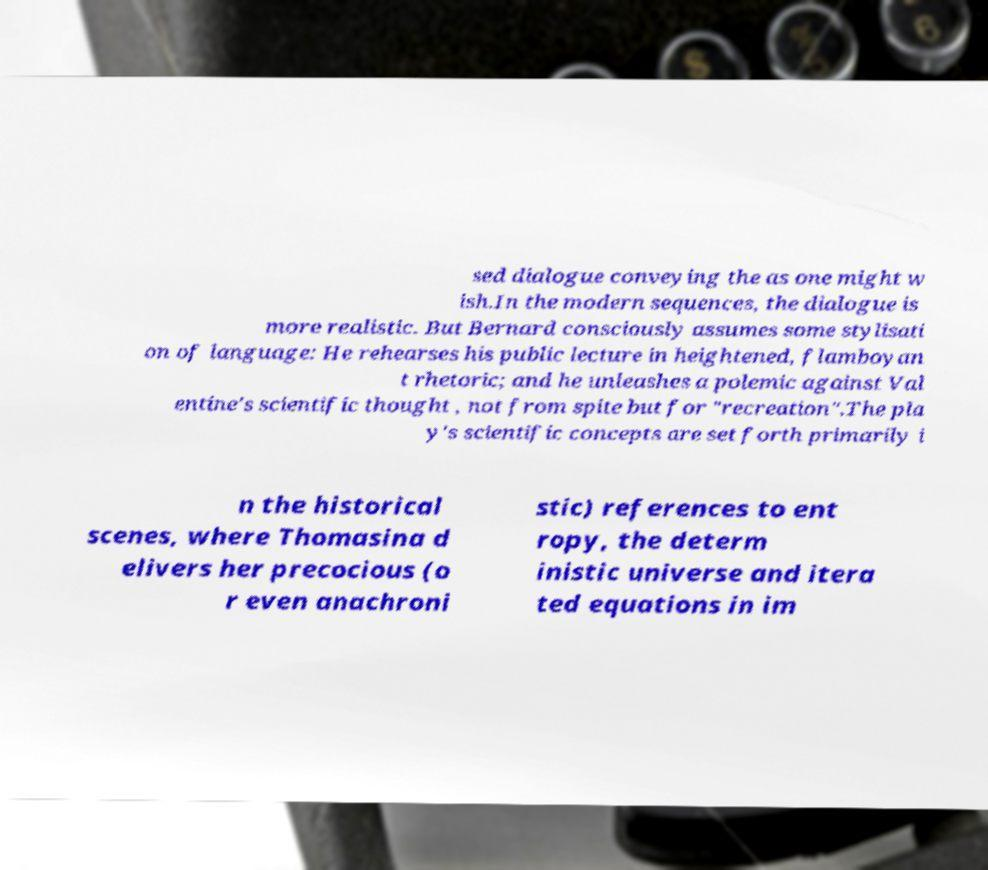Please read and relay the text visible in this image. What does it say? sed dialogue conveying the as one might w ish.In the modern sequences, the dialogue is more realistic. But Bernard consciously assumes some stylisati on of language: He rehearses his public lecture in heightened, flamboyan t rhetoric; and he unleashes a polemic against Val entine's scientific thought , not from spite but for "recreation".The pla y's scientific concepts are set forth primarily i n the historical scenes, where Thomasina d elivers her precocious (o r even anachroni stic) references to ent ropy, the determ inistic universe and itera ted equations in im 